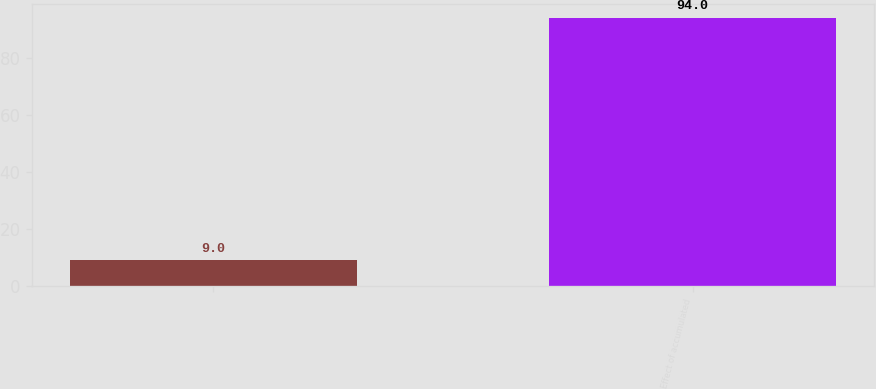<chart> <loc_0><loc_0><loc_500><loc_500><bar_chart><ecel><fcel>Effect of accumulated<nl><fcel>9<fcel>94<nl></chart> 